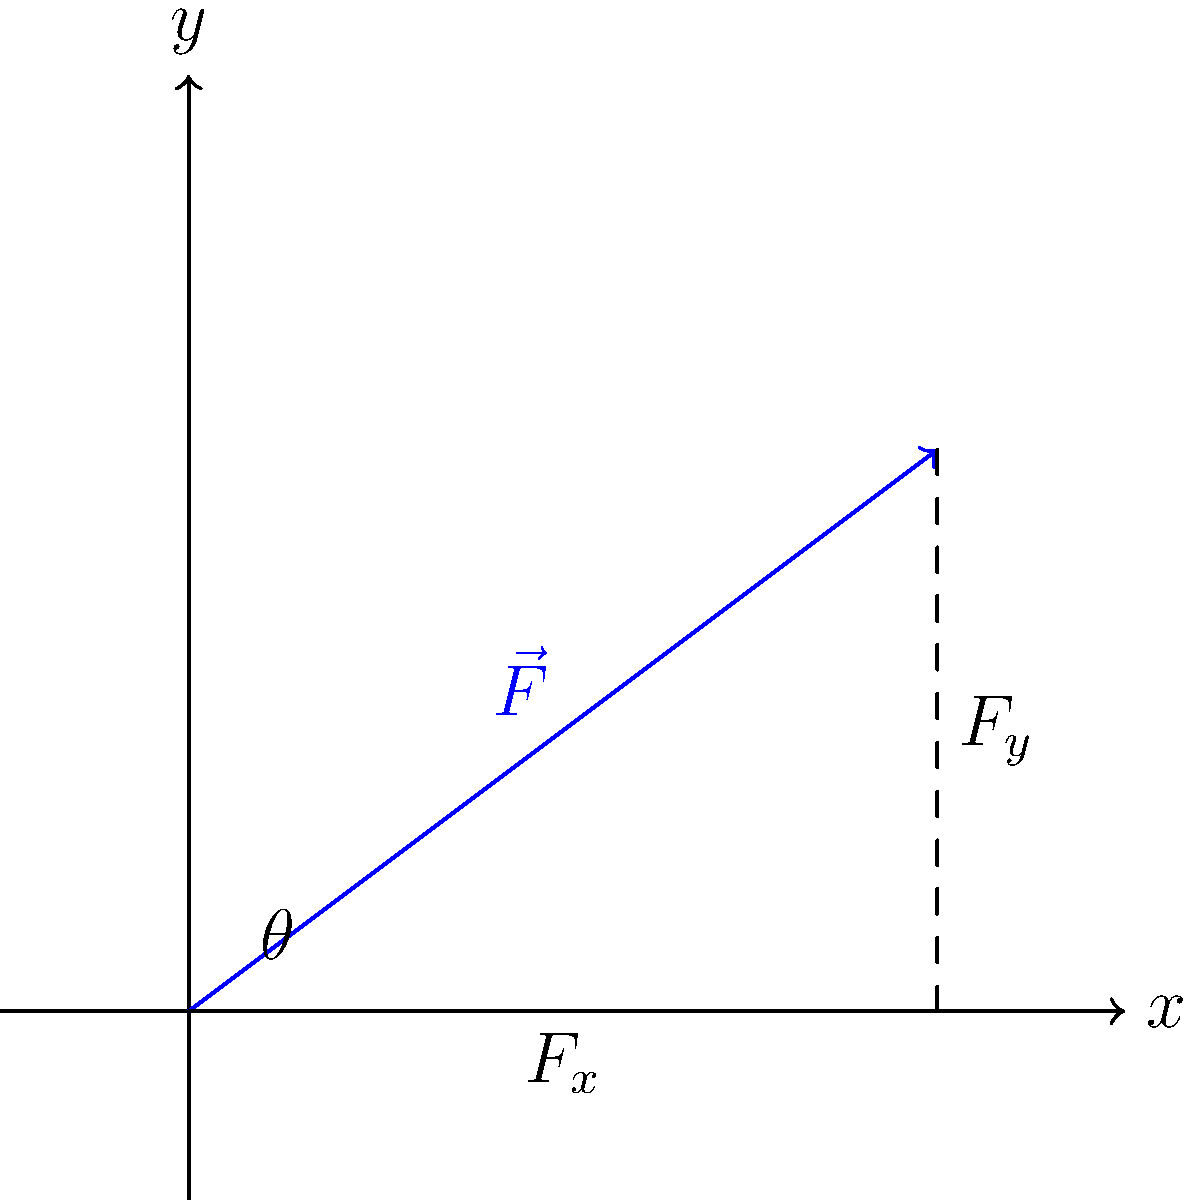A force vector $\vec{F}$ of magnitude 5 N is acting on an insect carcass at an angle of 36.87° from the horizontal. Determine the x and y components of this force vector to analyze how environmental factors might affect the decomposition process. To resolve the force vector into its x and y components, we'll use trigonometric functions. Here's the step-by-step process:

1) Given:
   - Force magnitude $|\vec{F}| = 5$ N
   - Angle $\theta = 36.87°$

2) For the x-component ($F_x$):
   $F_x = |\vec{F}| \cos(\theta)$
   $F_x = 5 \cos(36.87°)$
   $F_x \approx 4$ N

3) For the y-component ($F_y$):
   $F_y = |\vec{F}| \sin(\theta)$
   $F_y = 5 \sin(36.87°)$
   $F_y \approx 3$ N

4) Verify using the Pythagorean theorem:
   $|\vec{F}|^2 = F_x^2 + F_y^2$
   $5^2 \approx 4^2 + 3^2$
   $25 \approx 25$

The x-component represents the horizontal force, which could relate to factors like wind or surface friction. The y-component represents the vertical force, which might correspond to gravitational effects or vertical air currents. These components help in analyzing how environmental factors might influence the insect carcass's position and decomposition rate.
Answer: $F_x \approx 4$ N, $F_y \approx 3$ N 